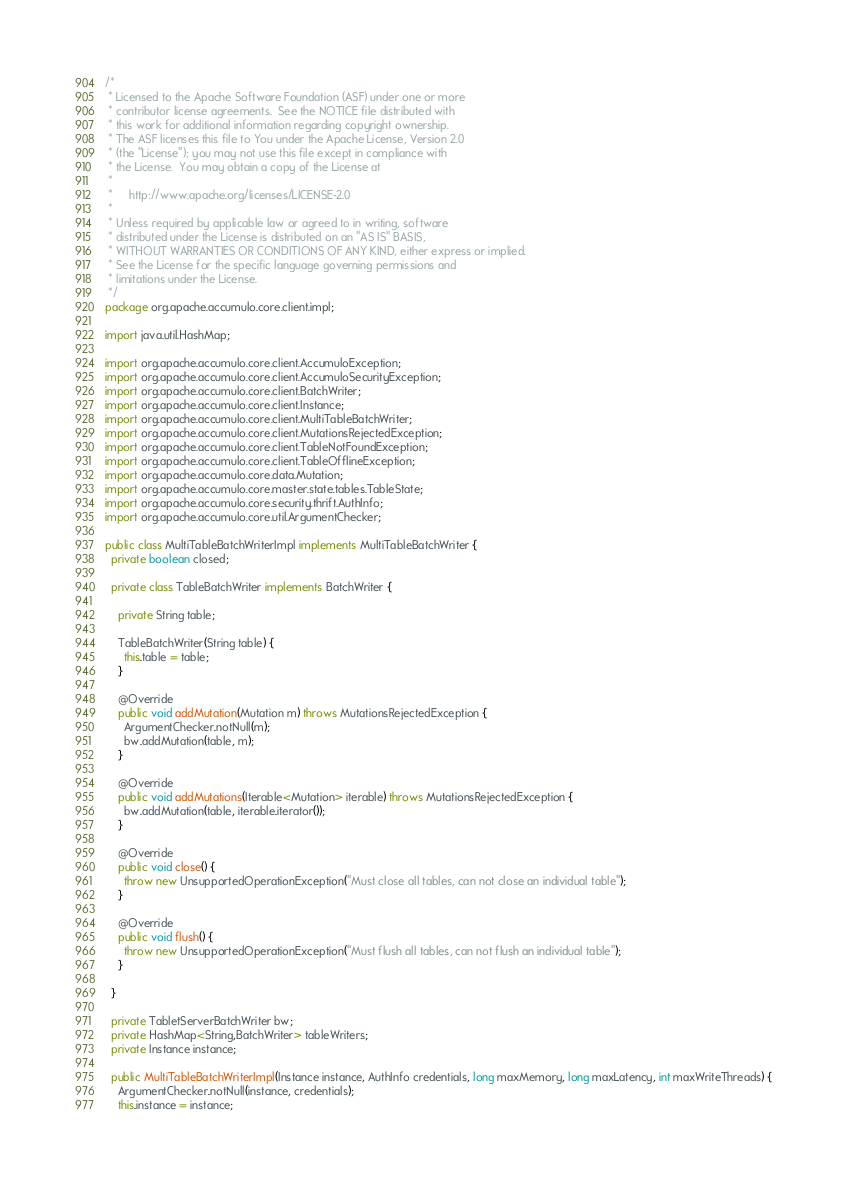Convert code to text. <code><loc_0><loc_0><loc_500><loc_500><_Java_>/*
 * Licensed to the Apache Software Foundation (ASF) under one or more
 * contributor license agreements.  See the NOTICE file distributed with
 * this work for additional information regarding copyright ownership.
 * The ASF licenses this file to You under the Apache License, Version 2.0
 * (the "License"); you may not use this file except in compliance with
 * the License.  You may obtain a copy of the License at
 *
 *     http://www.apache.org/licenses/LICENSE-2.0
 *
 * Unless required by applicable law or agreed to in writing, software
 * distributed under the License is distributed on an "AS IS" BASIS,
 * WITHOUT WARRANTIES OR CONDITIONS OF ANY KIND, either express or implied.
 * See the License for the specific language governing permissions and
 * limitations under the License.
 */
package org.apache.accumulo.core.client.impl;

import java.util.HashMap;

import org.apache.accumulo.core.client.AccumuloException;
import org.apache.accumulo.core.client.AccumuloSecurityException;
import org.apache.accumulo.core.client.BatchWriter;
import org.apache.accumulo.core.client.Instance;
import org.apache.accumulo.core.client.MultiTableBatchWriter;
import org.apache.accumulo.core.client.MutationsRejectedException;
import org.apache.accumulo.core.client.TableNotFoundException;
import org.apache.accumulo.core.client.TableOfflineException;
import org.apache.accumulo.core.data.Mutation;
import org.apache.accumulo.core.master.state.tables.TableState;
import org.apache.accumulo.core.security.thrift.AuthInfo;
import org.apache.accumulo.core.util.ArgumentChecker;

public class MultiTableBatchWriterImpl implements MultiTableBatchWriter {
  private boolean closed;
  
  private class TableBatchWriter implements BatchWriter {
    
    private String table;
    
    TableBatchWriter(String table) {
      this.table = table;
    }
    
    @Override
    public void addMutation(Mutation m) throws MutationsRejectedException {
      ArgumentChecker.notNull(m);
      bw.addMutation(table, m);
    }
    
    @Override
    public void addMutations(Iterable<Mutation> iterable) throws MutationsRejectedException {
      bw.addMutation(table, iterable.iterator());
    }
    
    @Override
    public void close() {
      throw new UnsupportedOperationException("Must close all tables, can not close an individual table");
    }
    
    @Override
    public void flush() {
      throw new UnsupportedOperationException("Must flush all tables, can not flush an individual table");
    }
    
  }
  
  private TabletServerBatchWriter bw;
  private HashMap<String,BatchWriter> tableWriters;
  private Instance instance;
  
  public MultiTableBatchWriterImpl(Instance instance, AuthInfo credentials, long maxMemory, long maxLatency, int maxWriteThreads) {
    ArgumentChecker.notNull(instance, credentials);
    this.instance = instance;</code> 